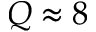<formula> <loc_0><loc_0><loc_500><loc_500>Q \approx 8</formula> 